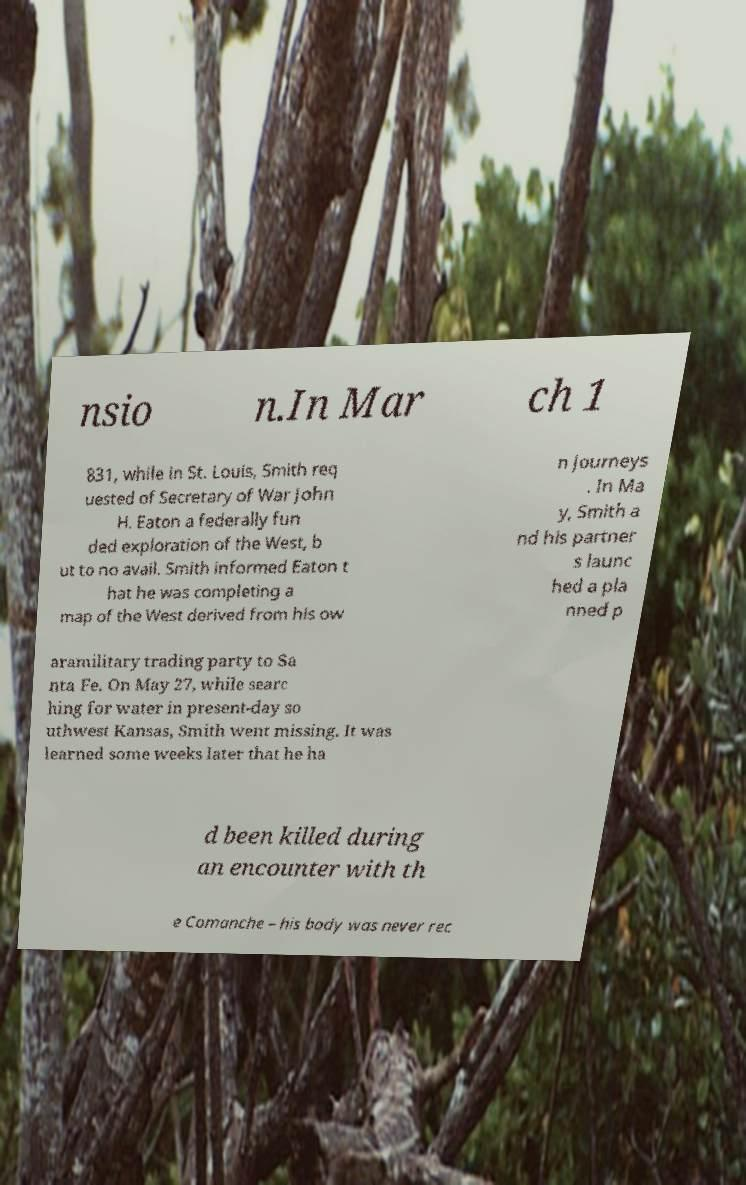Can you accurately transcribe the text from the provided image for me? nsio n.In Mar ch 1 831, while in St. Louis, Smith req uested of Secretary of War John H. Eaton a federally fun ded exploration of the West, b ut to no avail. Smith informed Eaton t hat he was completing a map of the West derived from his ow n journeys . In Ma y, Smith a nd his partner s launc hed a pla nned p aramilitary trading party to Sa nta Fe. On May 27, while searc hing for water in present-day so uthwest Kansas, Smith went missing. It was learned some weeks later that he ha d been killed during an encounter with th e Comanche – his body was never rec 